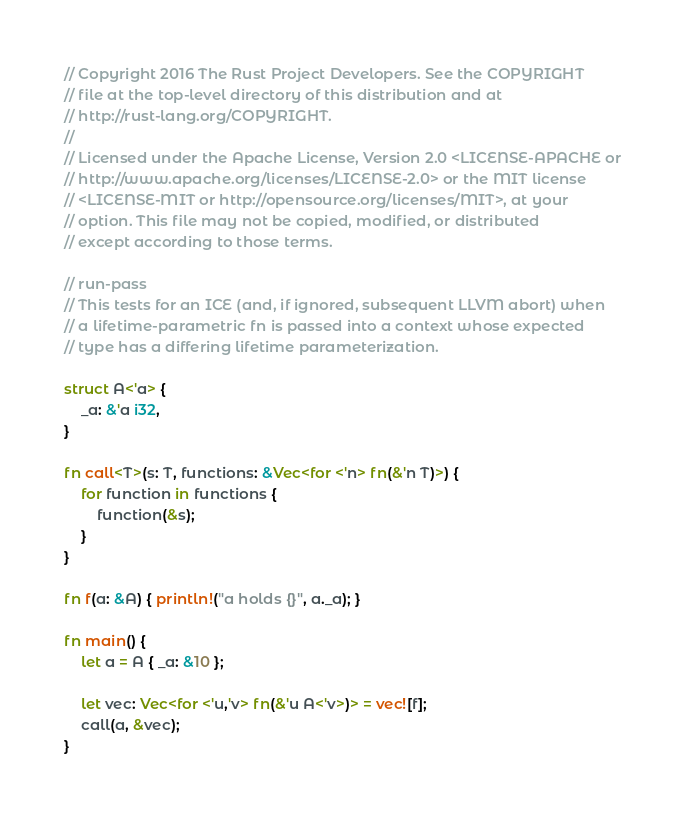Convert code to text. <code><loc_0><loc_0><loc_500><loc_500><_Rust_>// Copyright 2016 The Rust Project Developers. See the COPYRIGHT
// file at the top-level directory of this distribution and at
// http://rust-lang.org/COPYRIGHT.
//
// Licensed under the Apache License, Version 2.0 <LICENSE-APACHE or
// http://www.apache.org/licenses/LICENSE-2.0> or the MIT license
// <LICENSE-MIT or http://opensource.org/licenses/MIT>, at your
// option. This file may not be copied, modified, or distributed
// except according to those terms.

// run-pass
// This tests for an ICE (and, if ignored, subsequent LLVM abort) when
// a lifetime-parametric fn is passed into a context whose expected
// type has a differing lifetime parameterization.

struct A<'a> {
    _a: &'a i32,
}

fn call<T>(s: T, functions: &Vec<for <'n> fn(&'n T)>) {
    for function in functions {
        function(&s);
    }
}

fn f(a: &A) { println!("a holds {}", a._a); }

fn main() {
    let a = A { _a: &10 };

    let vec: Vec<for <'u,'v> fn(&'u A<'v>)> = vec![f];
    call(a, &vec);
}
</code> 